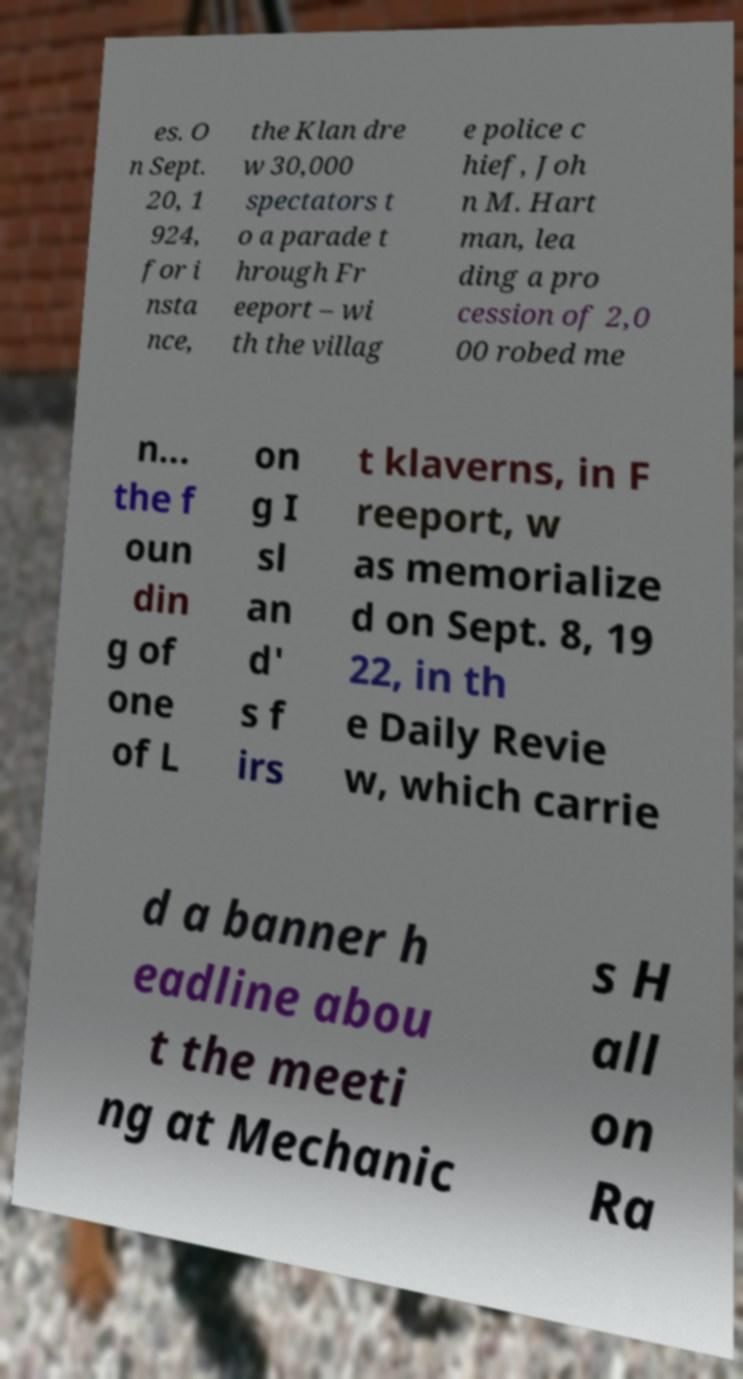Please identify and transcribe the text found in this image. es. O n Sept. 20, 1 924, for i nsta nce, the Klan dre w 30,000 spectators t o a parade t hrough Fr eeport – wi th the villag e police c hief, Joh n M. Hart man, lea ding a pro cession of 2,0 00 robed me n... the f oun din g of one of L on g I sl an d' s f irs t klaverns, in F reeport, w as memorialize d on Sept. 8, 19 22, in th e Daily Revie w, which carrie d a banner h eadline abou t the meeti ng at Mechanic s H all on Ra 